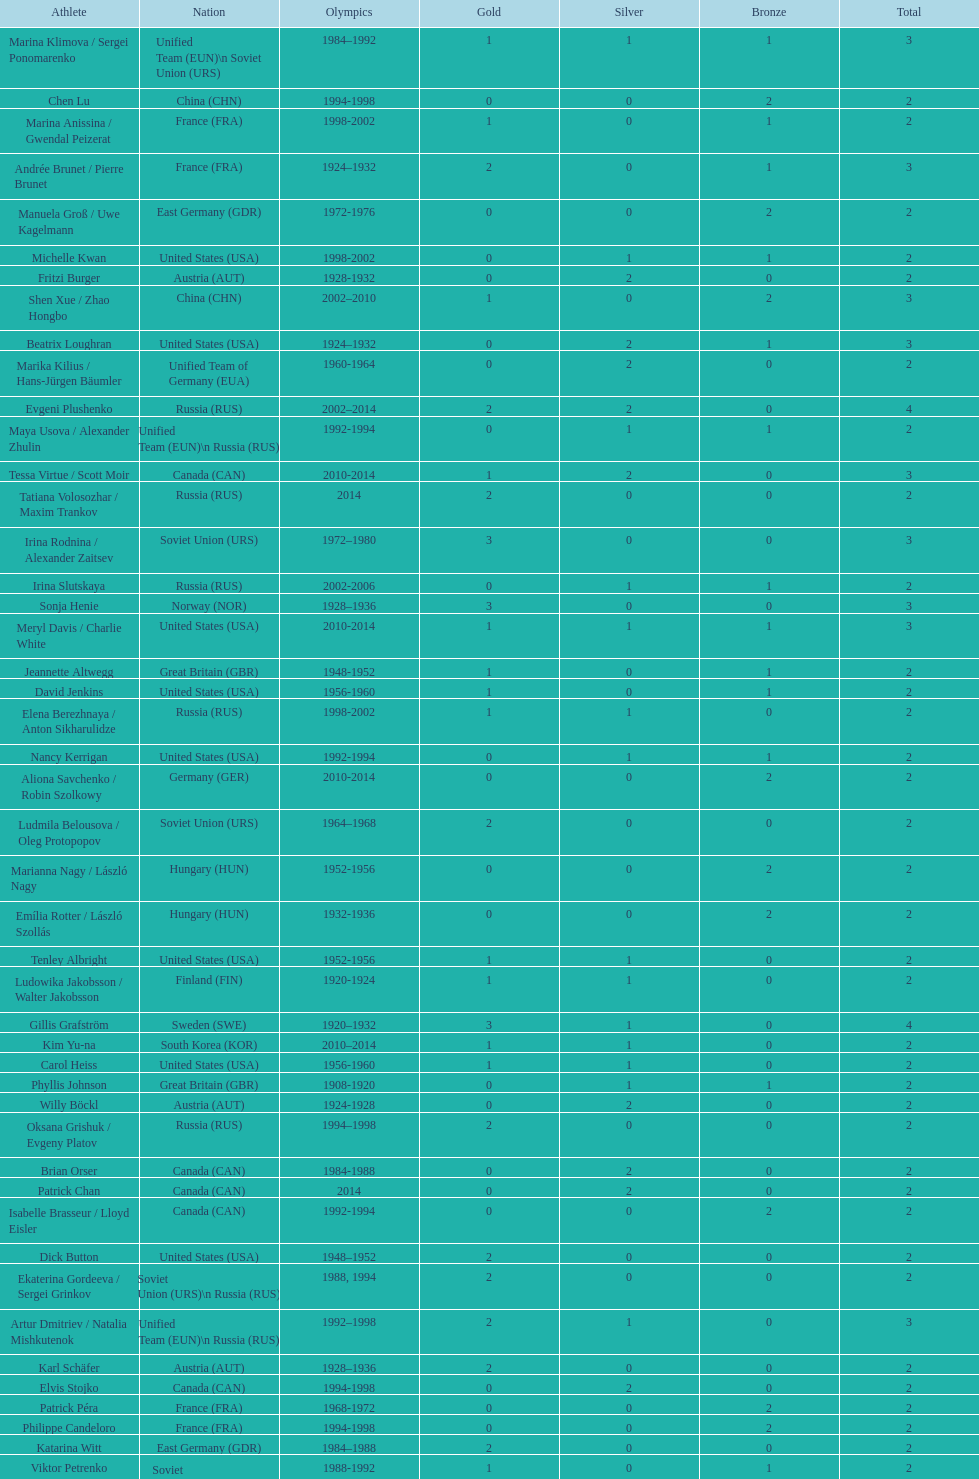How many medals have sweden and norway won combined? 7. 